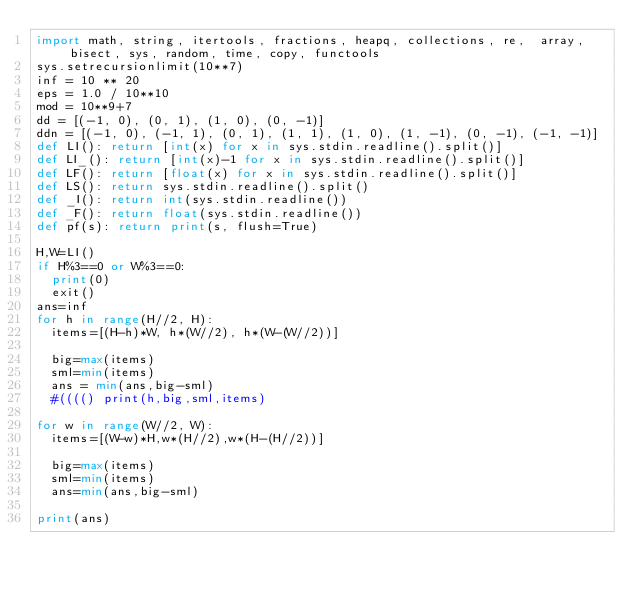<code> <loc_0><loc_0><loc_500><loc_500><_Python_>import math, string, itertools, fractions, heapq, collections, re,  array, bisect, sys, random, time, copy, functools
sys.setrecursionlimit(10**7)
inf = 10 ** 20
eps = 1.0 / 10**10
mod = 10**9+7
dd = [(-1, 0), (0, 1), (1, 0), (0, -1)]
ddn = [(-1, 0), (-1, 1), (0, 1), (1, 1), (1, 0), (1, -1), (0, -1), (-1, -1)]
def LI(): return [int(x) for x in sys.stdin.readline().split()]
def LI_(): return [int(x)-1 for x in sys.stdin.readline().split()]
def LF(): return [float(x) for x in sys.stdin.readline().split()]
def LS(): return sys.stdin.readline().split()
def _I(): return int(sys.stdin.readline())
def _F(): return float(sys.stdin.readline())
def pf(s): return print(s, flush=True)

H,W=LI()
if H%3==0 or W%3==0:
	print(0)
	exit()
ans=inf
for h in range(H//2, H):
	items=[(H-h)*W, h*(W//2), h*(W-(W//2))]

	big=max(items)
	sml=min(items)
	ans = min(ans,big-sml)
	#(((() print(h,big,sml,items)

for w in range(W//2, W):
	items=[(W-w)*H,w*(H//2),w*(H-(H//2))]

	big=max(items)
	sml=min(items)
	ans=min(ans,big-sml)

print(ans)
</code> 